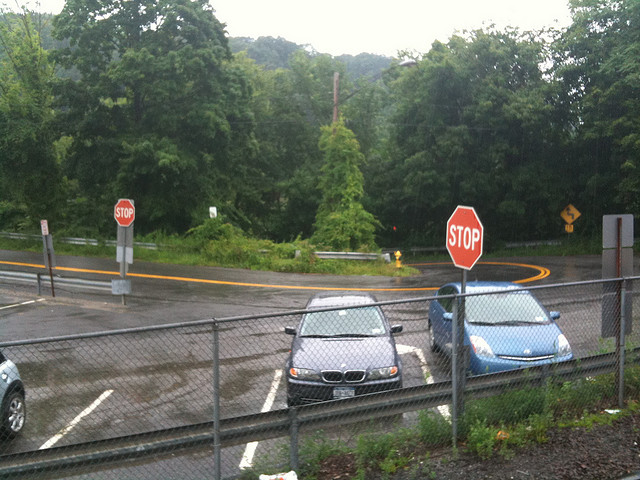Identify the text contained in this image. STOP STOP 